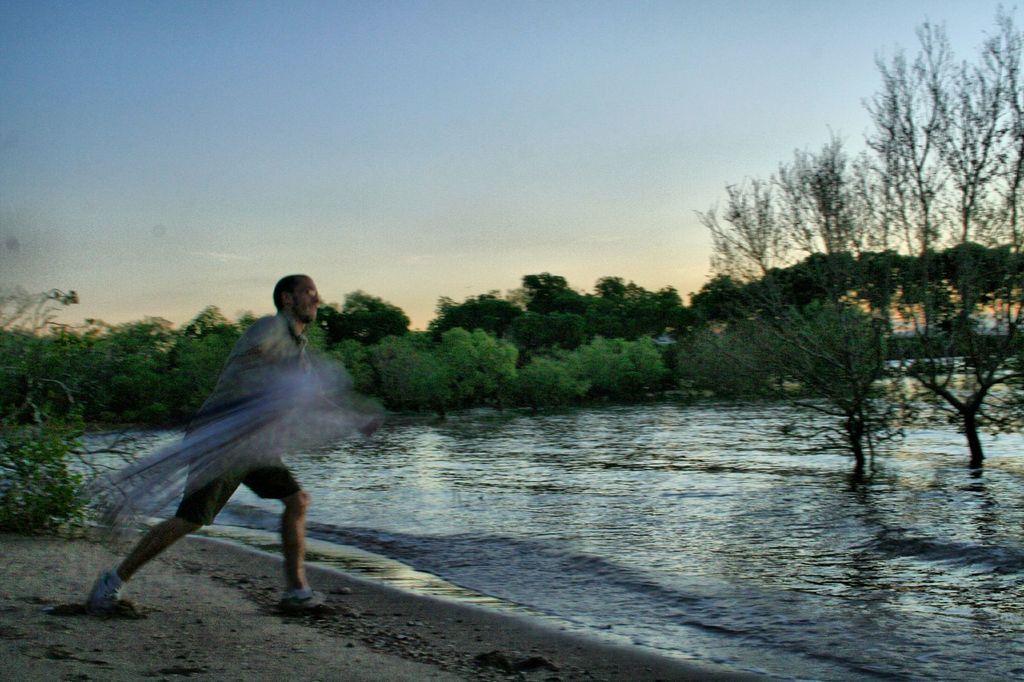Describe this image in one or two sentences. In this picture there is a man standing and holding the net. At the back there are trees. At the top there is sky. At the bottom there is water and there is ground. 